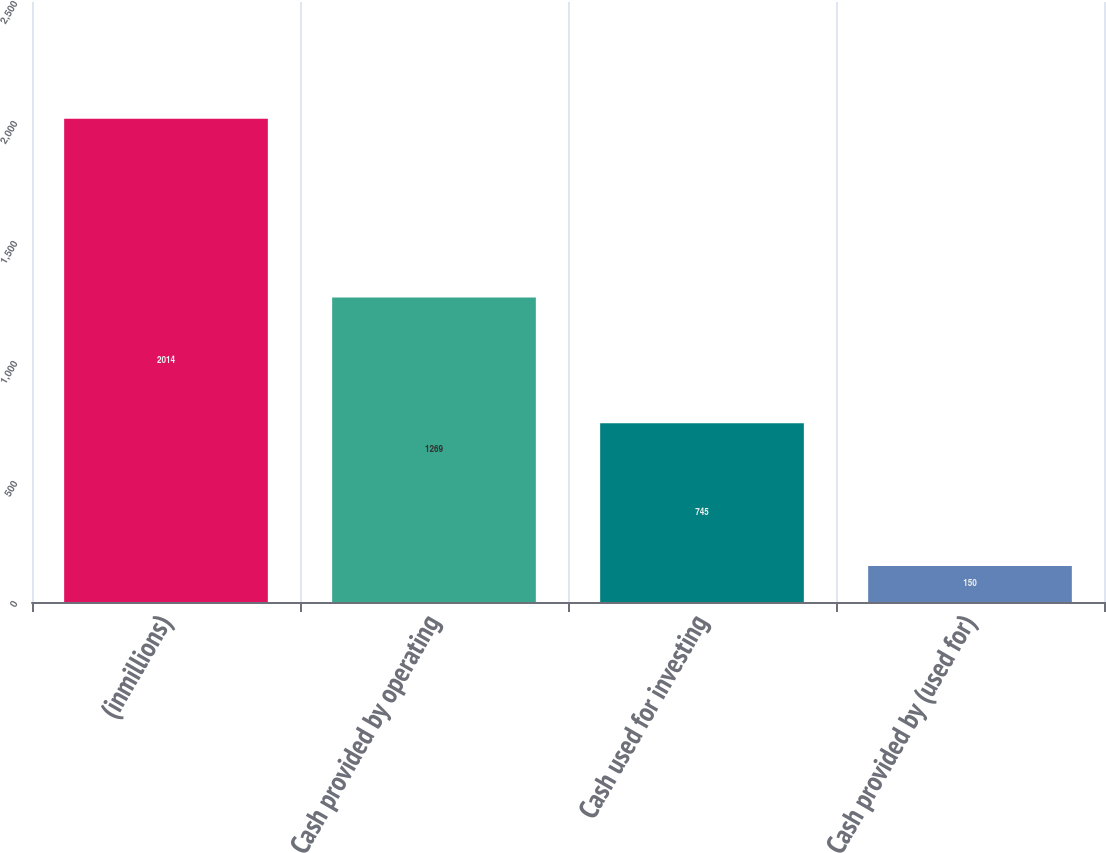Convert chart. <chart><loc_0><loc_0><loc_500><loc_500><bar_chart><fcel>(inmillions)<fcel>Cash provided by operating<fcel>Cash used for investing<fcel>Cash provided by (used for)<nl><fcel>2014<fcel>1269<fcel>745<fcel>150<nl></chart> 